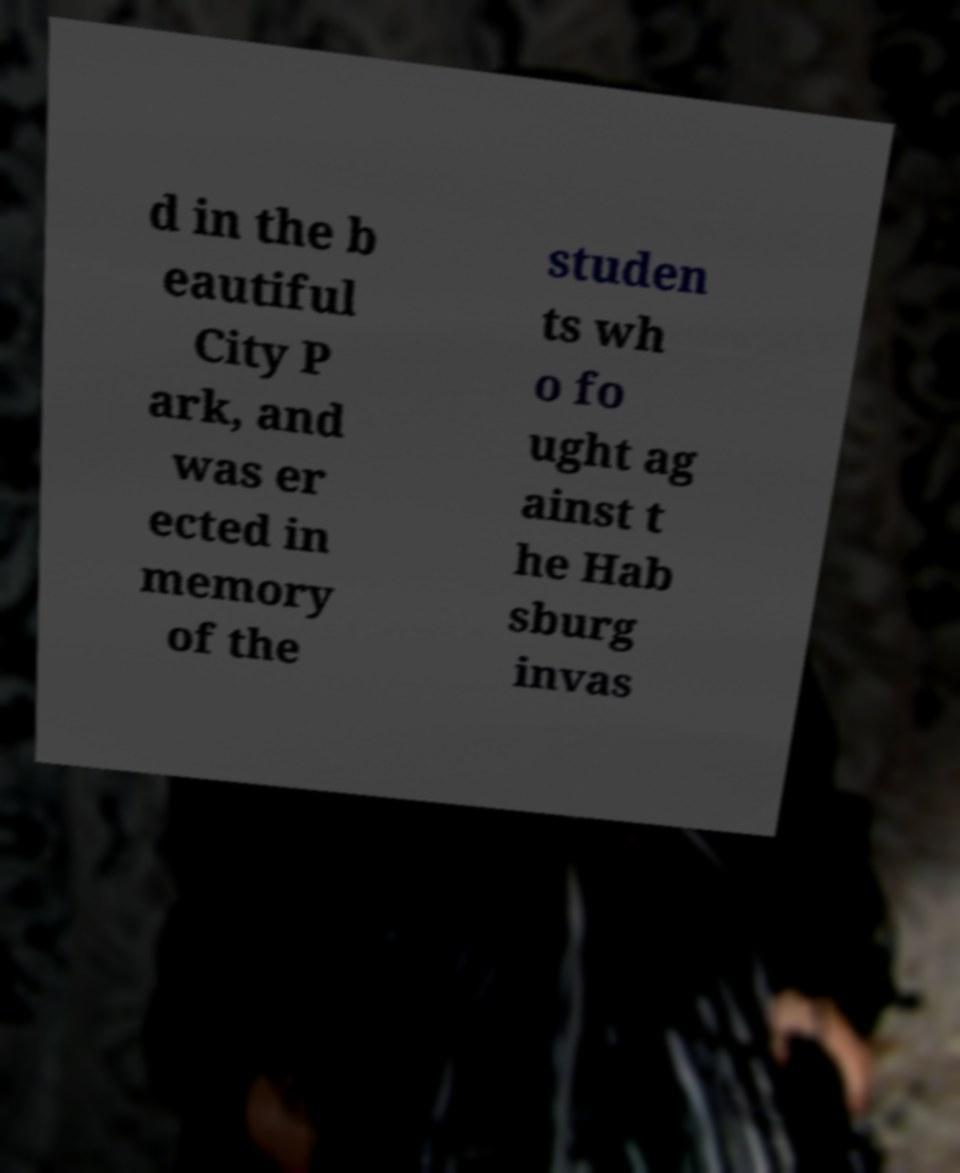Can you accurately transcribe the text from the provided image for me? d in the b eautiful City P ark, and was er ected in memory of the studen ts wh o fo ught ag ainst t he Hab sburg invas 